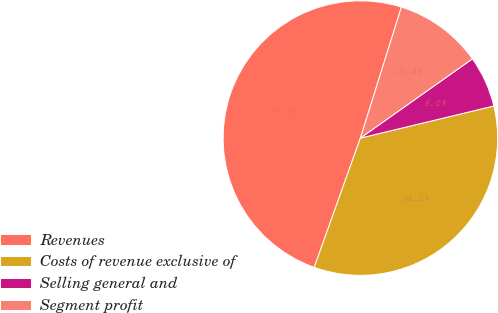<chart> <loc_0><loc_0><loc_500><loc_500><pie_chart><fcel>Revenues<fcel>Costs of revenue exclusive of<fcel>Selling general and<fcel>Segment profit<nl><fcel>49.38%<fcel>34.22%<fcel>6.04%<fcel>10.37%<nl></chart> 